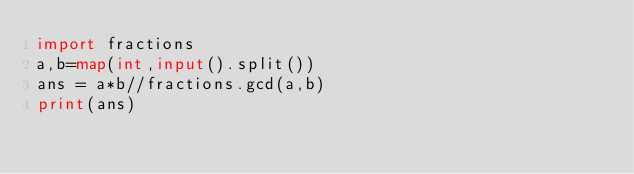Convert code to text. <code><loc_0><loc_0><loc_500><loc_500><_Python_>import fractions
a,b=map(int,input().split())
ans = a*b//fractions.gcd(a,b)
print(ans)</code> 